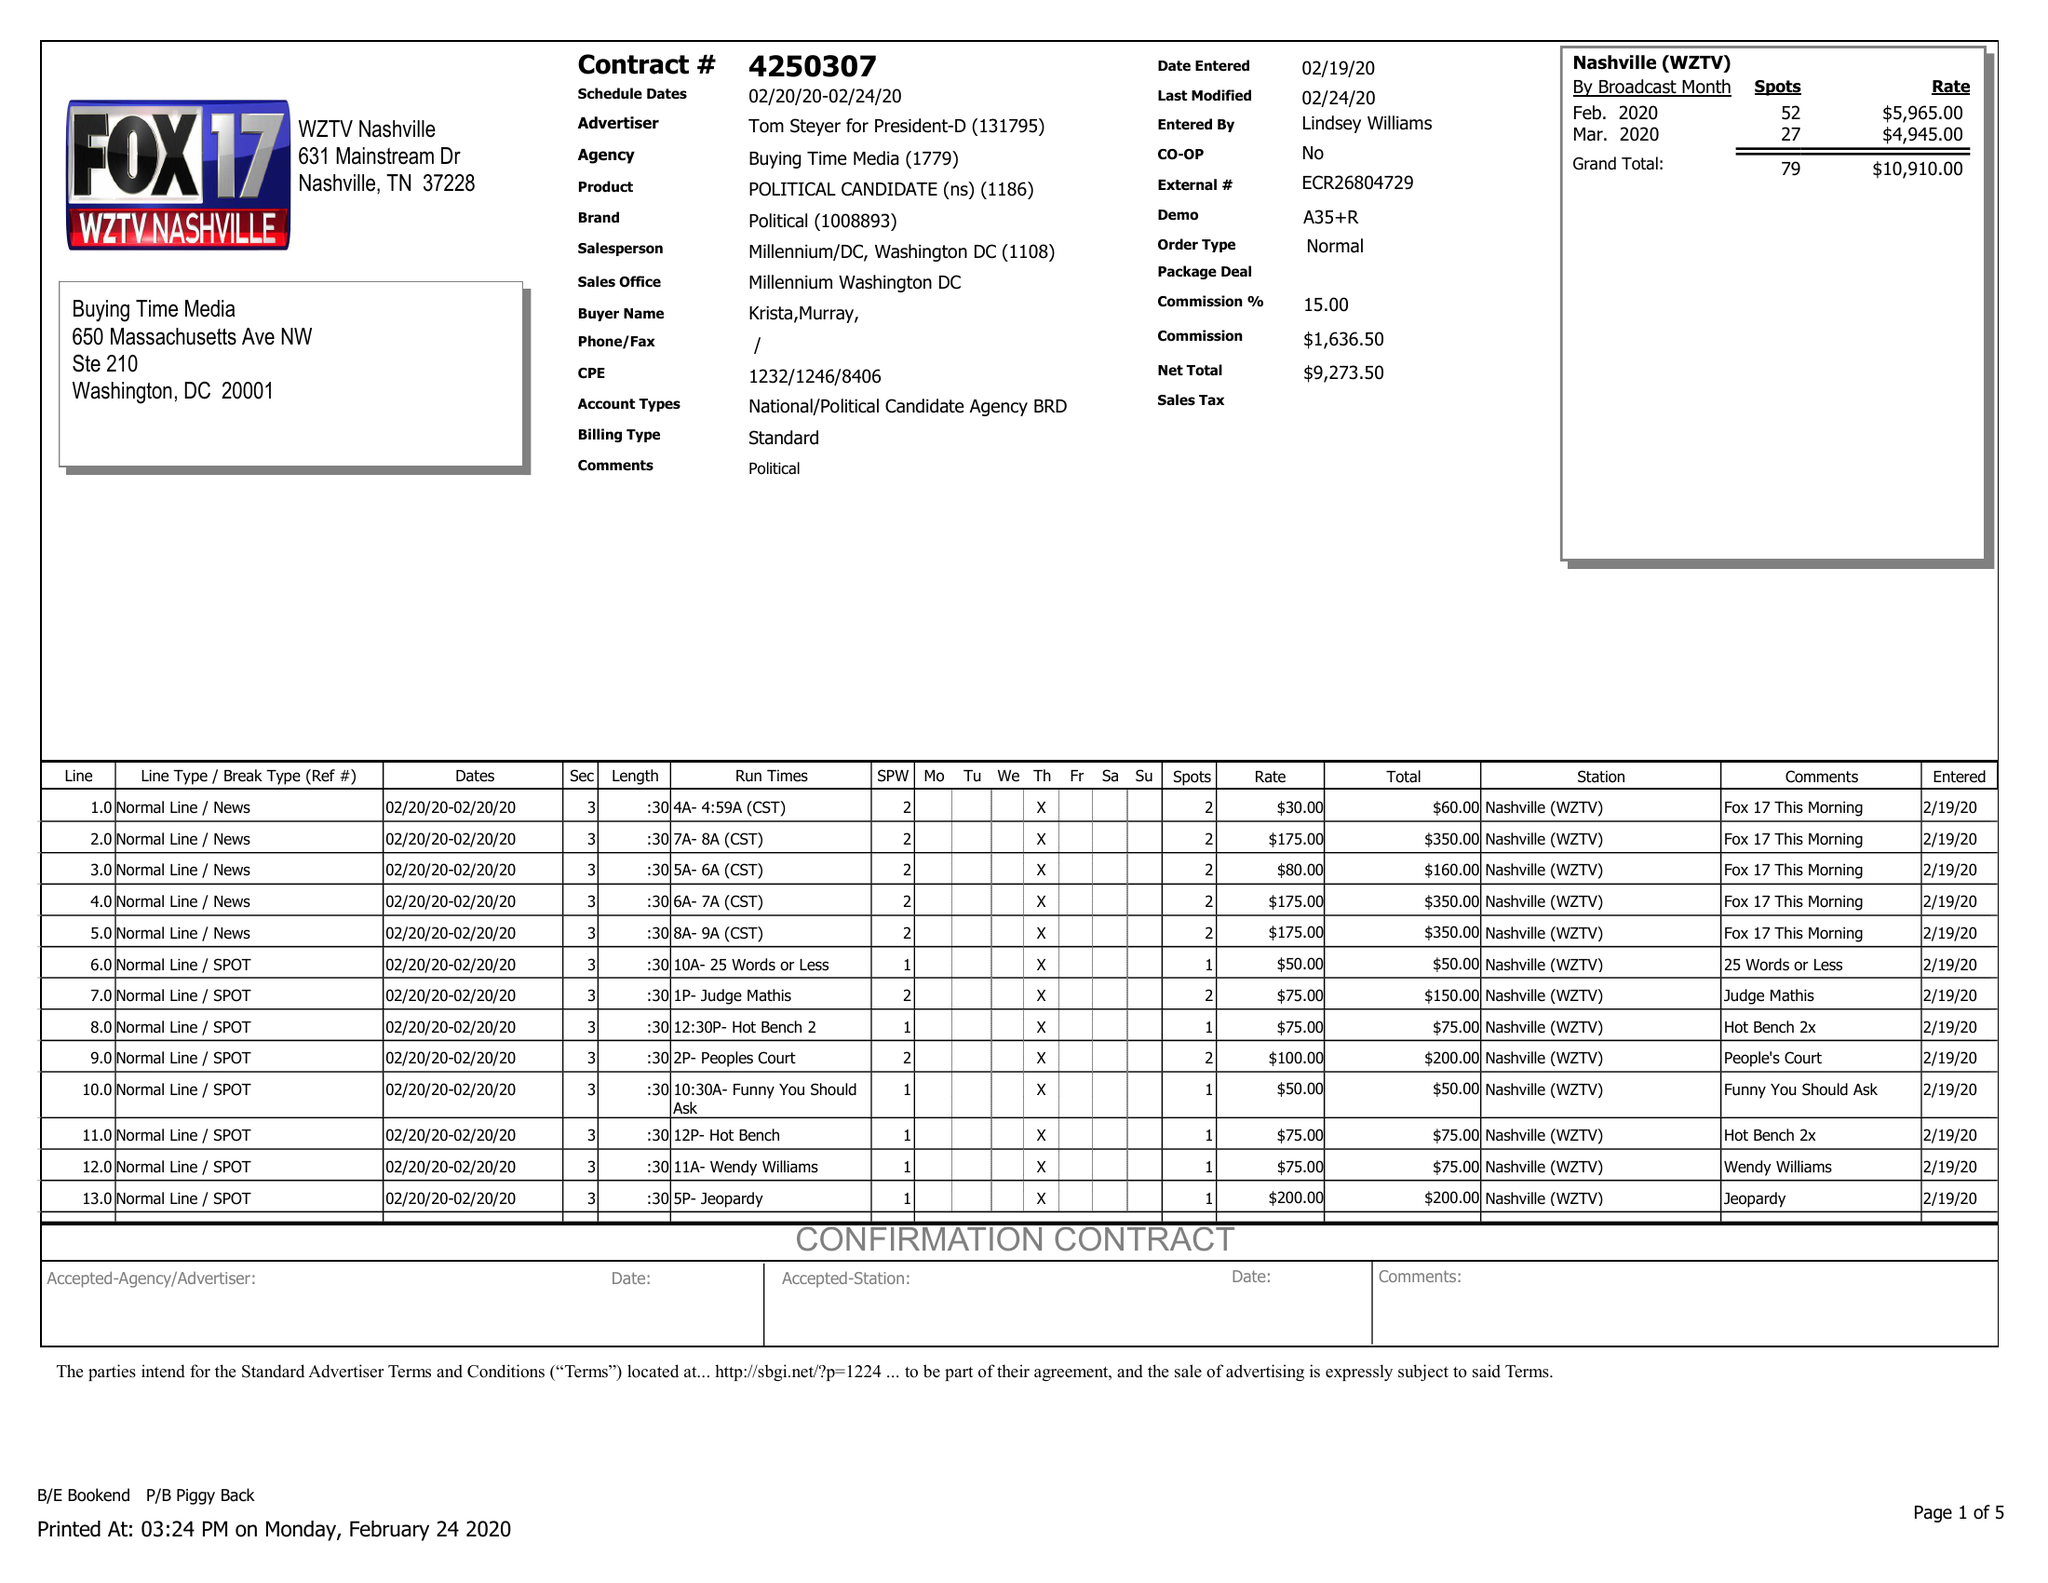What is the value for the gross_amount?
Answer the question using a single word or phrase. 10910.00 